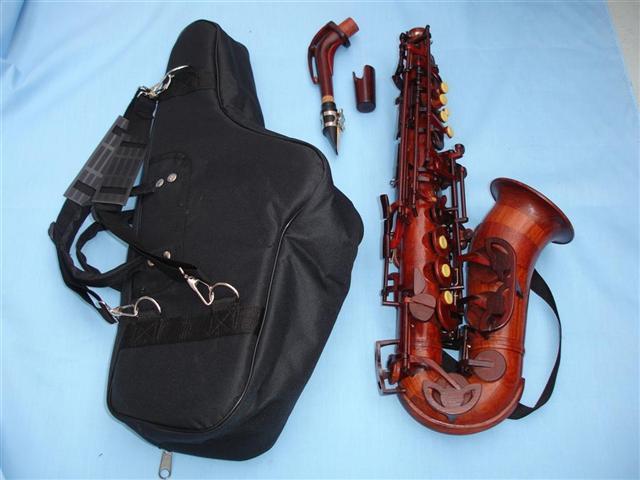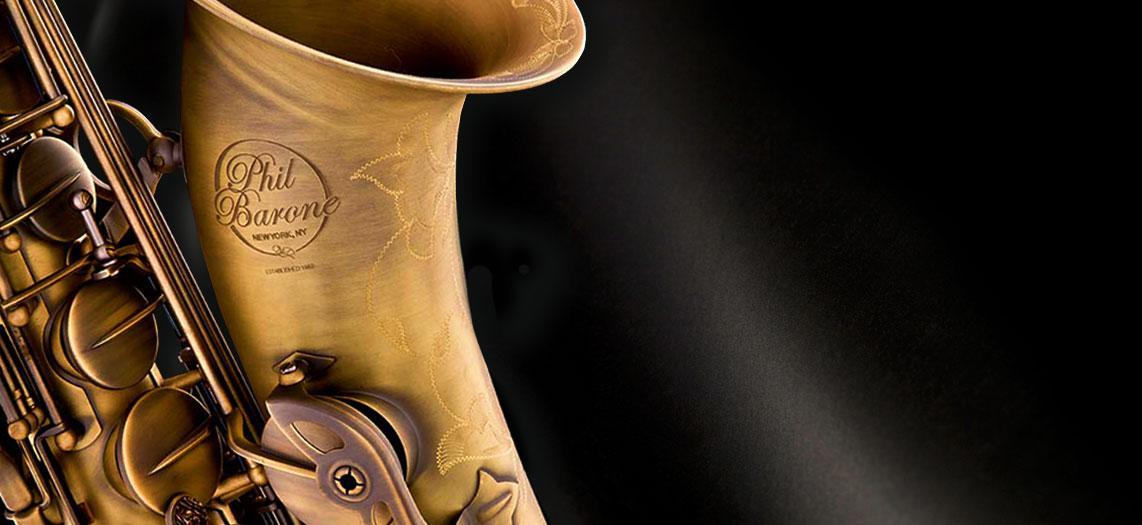The first image is the image on the left, the second image is the image on the right. For the images shown, is this caption "An image shows a person in a green shirt and jeans holding an instrument." true? Answer yes or no. No. The first image is the image on the left, the second image is the image on the right. For the images shown, is this caption "A person wearing glasses holds a saxophone in the left image." true? Answer yes or no. No. 